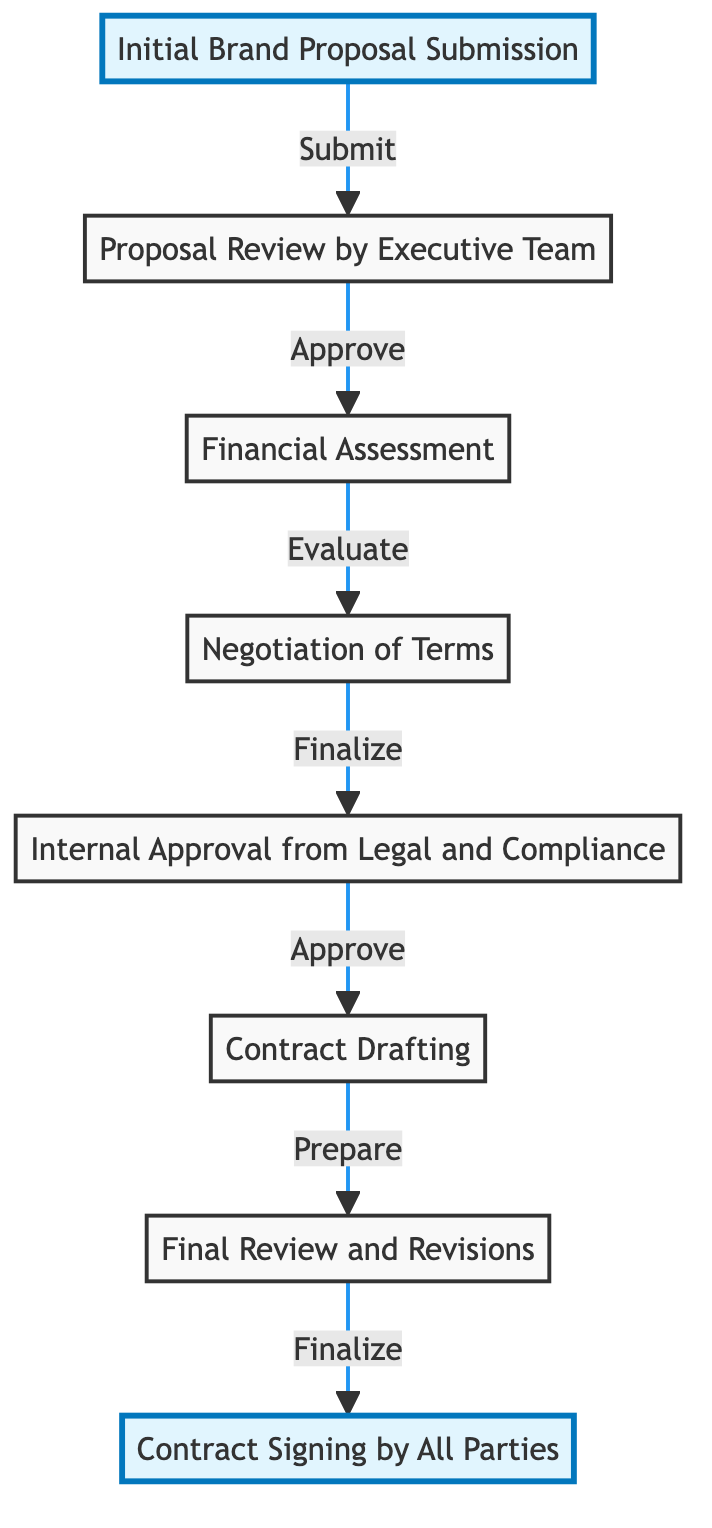What is the first step in the brand deal approval process? The diagram indicates that the first step is "Initial Brand Proposal Submission." This is the starting point of the flow, as represented by the first node in the diagram.
Answer: Initial Brand Proposal Submission How many steps are there in the process? The diagram shows a total of eight steps that lead from the initial proposal to the final contract signing. Each step is represented by a distinct node.
Answer: 8 What step follows the Financial Assessment? After the "Financial Assessment" step, the next step shown in the diagram is "Negotiation of Terms." This follows logically in the sequence of the brand deal approval process.
Answer: Negotiation of Terms Which parties are involved in the Contract Signing step? The diagram specifies that the "Contract Signing" involves both the brand and the poker player. This is the final step where both parties must sign the contract to finalize the deal.
Answer: Brand and poker player What is necessary before the Contract Drafting stage? According to the flow chart, "Internal Approval from Legal and Compliance" must occur before "Contract Drafting." This step ensures that the agreement meets legal requirements prior to drafting.
Answer: Internal Approval from Legal and Compliance Which step involves evaluating budget considerations? The "Financial Assessment" step is where budget considerations are evaluated as part of the deal's financial implications. This is an important step in determining if the deal is feasible.
Answer: Financial Assessment What is the last step in the brand deal approval process? The last step in the diagram is "Contract Signing by All Parties," indicating that this is the final action taken to close the deal after all previous steps have been completed.
Answer: Contract Signing by All Parties How does one proposal lead to another step? The progression in the flow chart shows arrows connecting each step, signifying that one proposal directly leads to the next action necessary in the approval process, starting from proposal submission through to contract signing.
Answer: Through arrows indicating flow What is the role of the Executive Team in the process? The "Proposal Review by Executive Team" indicates that the Executive Team is responsible for reviewing the initial brand proposal to ensure it aligns with the overall brand strategy before moving forward.
Answer: Proposal Review by Executive Team 